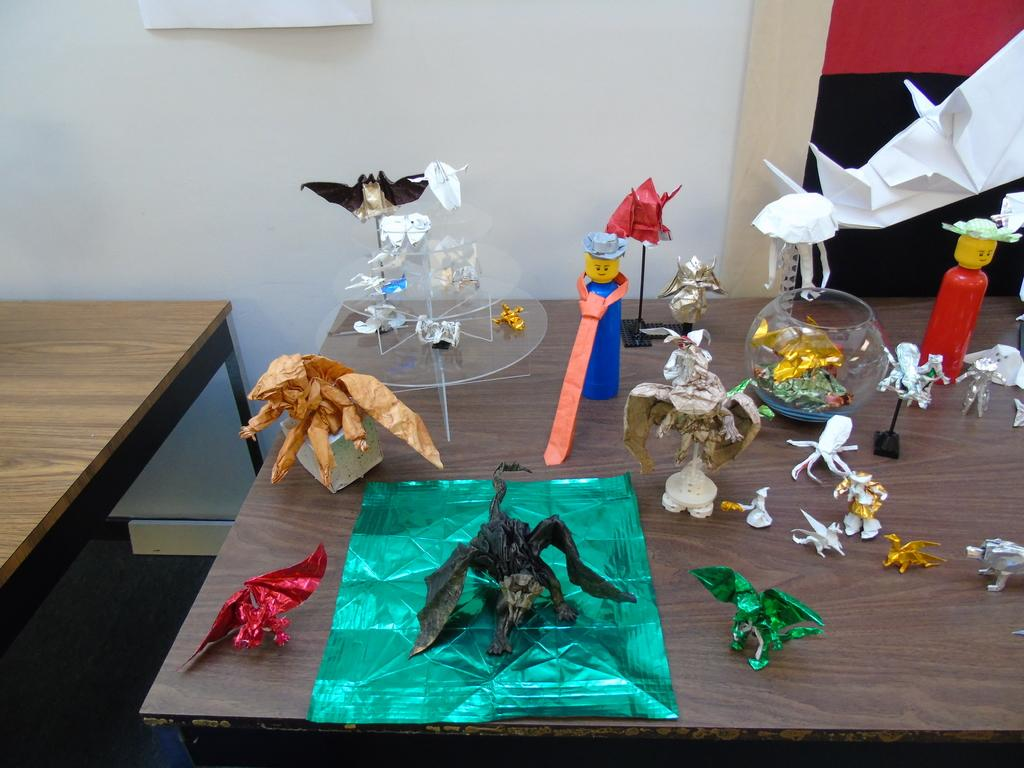What can be seen in the background of the image? There is a wall in the image. What is located on the floor in the image? There is a table on the floor in the image. What is placed on the table in the image? There are many toys on the table. What type of whip can be seen on the table in the image? There is no whip present on the table in the image; it is covered with toys. How does the pump function in the image? There is no pump present in the image; it only features a wall, a table, and toys. 